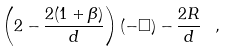Convert formula to latex. <formula><loc_0><loc_0><loc_500><loc_500>\left ( 2 - \frac { 2 ( 1 + \beta ) } { d } \right ) ( - \Box ) - \frac { 2 R } { d } \, \ ,</formula> 